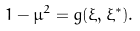Convert formula to latex. <formula><loc_0><loc_0><loc_500><loc_500>1 - \mu ^ { 2 } = g ( \xi , \xi ^ { \ast } ) .</formula> 